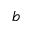<formula> <loc_0><loc_0><loc_500><loc_500>b</formula> 